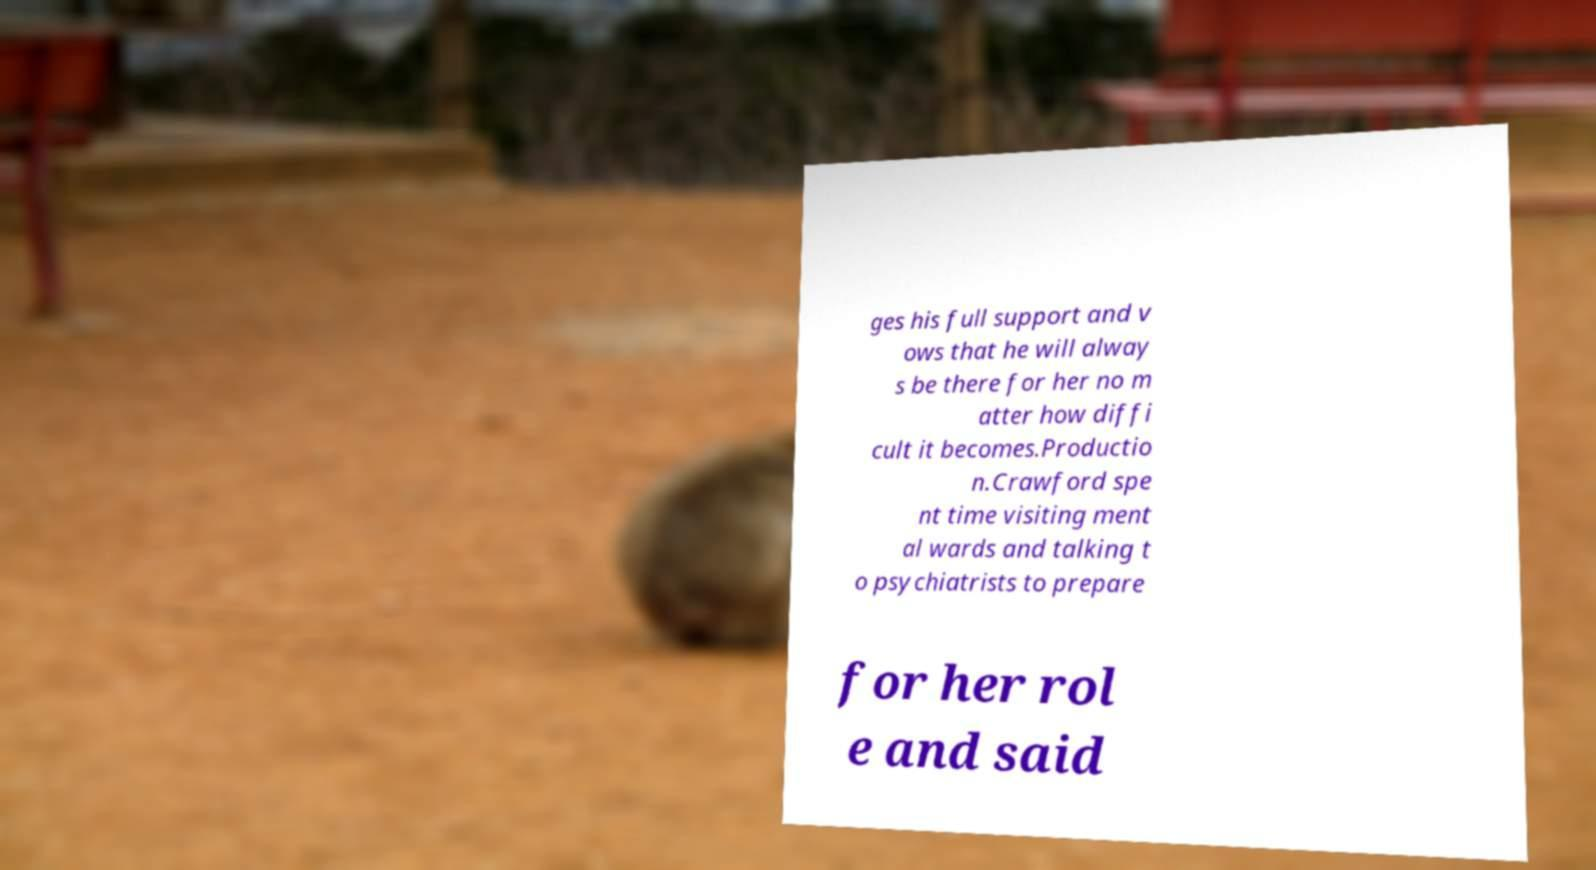Can you read and provide the text displayed in the image?This photo seems to have some interesting text. Can you extract and type it out for me? ges his full support and v ows that he will alway s be there for her no m atter how diffi cult it becomes.Productio n.Crawford spe nt time visiting ment al wards and talking t o psychiatrists to prepare for her rol e and said 